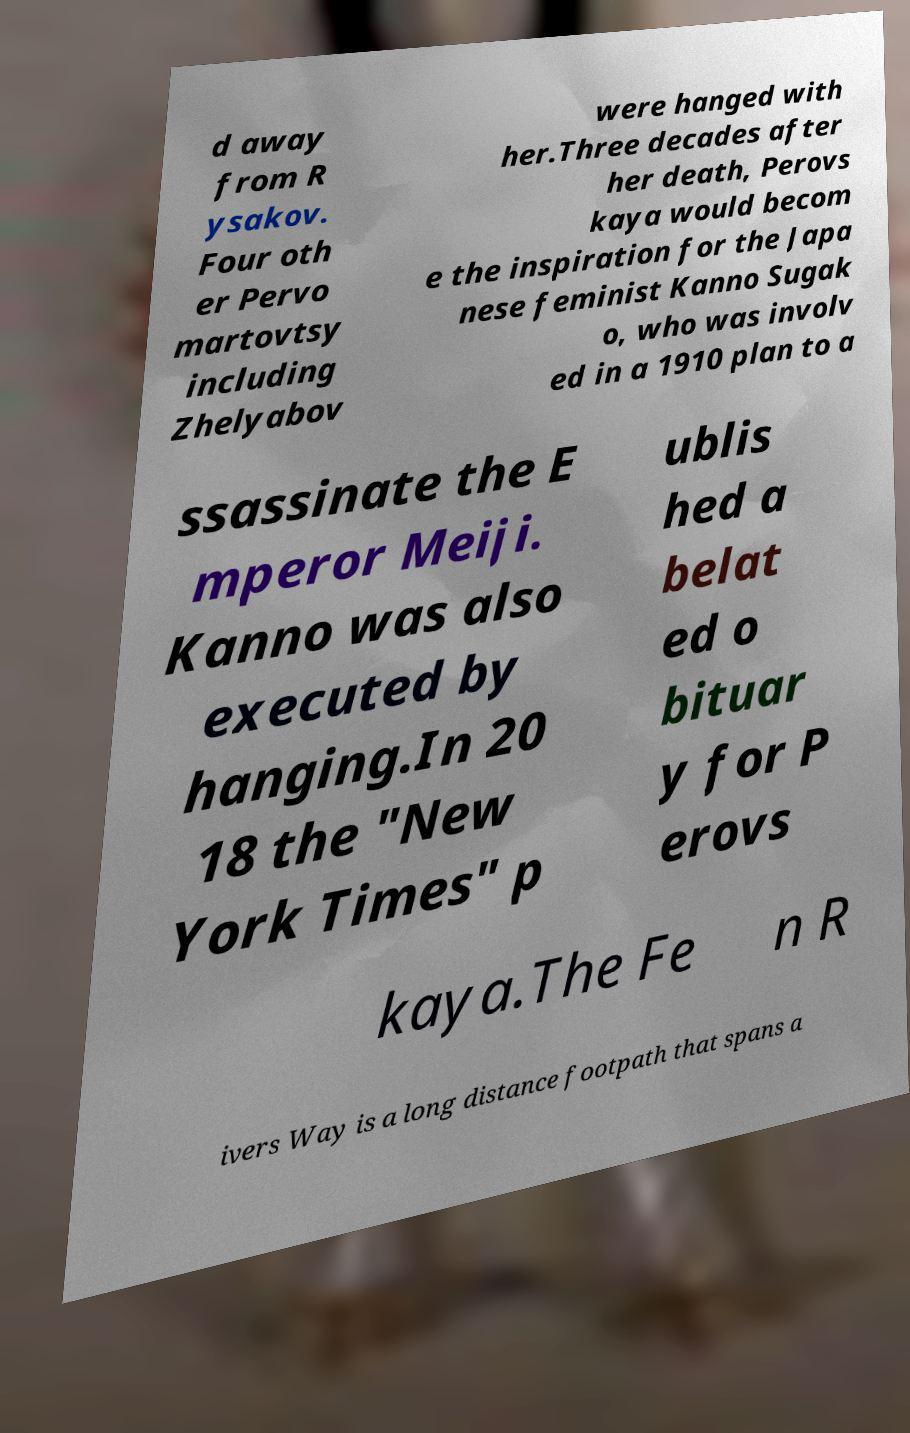For documentation purposes, I need the text within this image transcribed. Could you provide that? d away from R ysakov. Four oth er Pervo martovtsy including Zhelyabov were hanged with her.Three decades after her death, Perovs kaya would becom e the inspiration for the Japa nese feminist Kanno Sugak o, who was involv ed in a 1910 plan to a ssassinate the E mperor Meiji. Kanno was also executed by hanging.In 20 18 the "New York Times" p ublis hed a belat ed o bituar y for P erovs kaya.The Fe n R ivers Way is a long distance footpath that spans a 